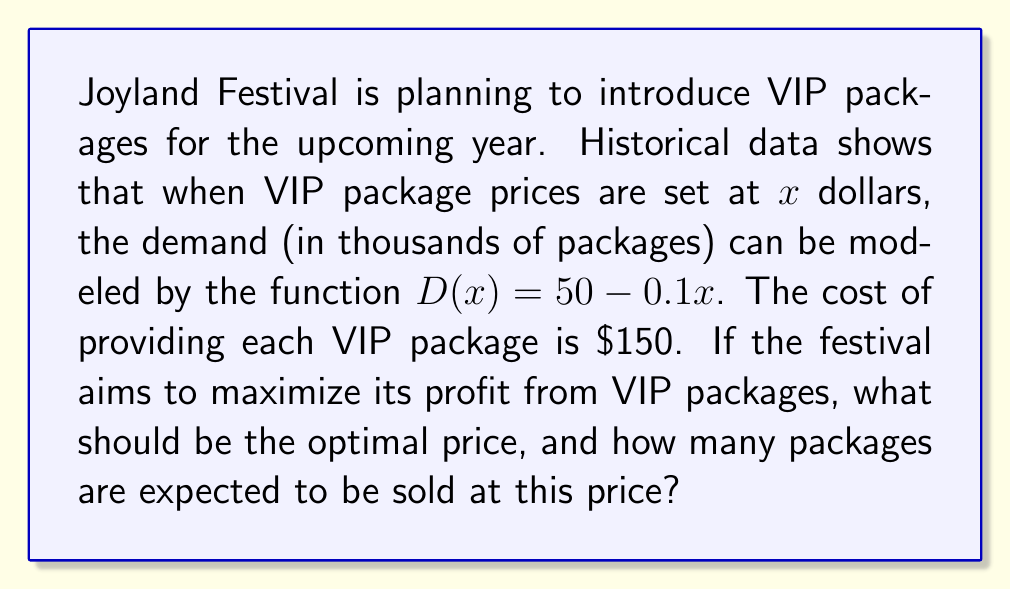Can you answer this question? To solve this problem, we need to follow these steps:

1) First, let's define the profit function. Profit is equal to revenue minus cost.

   Profit = Revenue - Cost
   $P(x) = xD(x) - 150D(x)$

   Where $x$ is the price per package and $D(x)$ is the demand function.

2) Substitute the demand function:
   $P(x) = x(50 - 0.1x) - 150(50 - 0.1x)$
   $P(x) = 50x - 0.1x^2 - 7500 + 15x$
   $P(x) = -0.1x^2 + 65x - 7500$

3) To find the maximum profit, we need to find the value of $x$ where the derivative of $P(x)$ is zero:

   $\frac{dP}{dx} = -0.2x + 65$

4) Set this equal to zero and solve for $x$:
   $-0.2x + 65 = 0$
   $-0.2x = -65$
   $x = 325$

5) To confirm this is a maximum (not a minimum), check the second derivative:
   $\frac{d^2P}{dx^2} = -0.2$, which is negative, confirming a maximum.

6) Therefore, the optimal price is $\$325$ per VIP package.

7) To find how many packages will be sold at this price, substitute $x=325$ into the demand function:
   $D(325) = 50 - 0.1(325) = 50 - 32.5 = 17.5$

Therefore, 17,500 VIP packages are expected to be sold at the optimal price.
Answer: The optimal price for VIP packages is $\$325$, and 17,500 packages are expected to be sold at this price. 